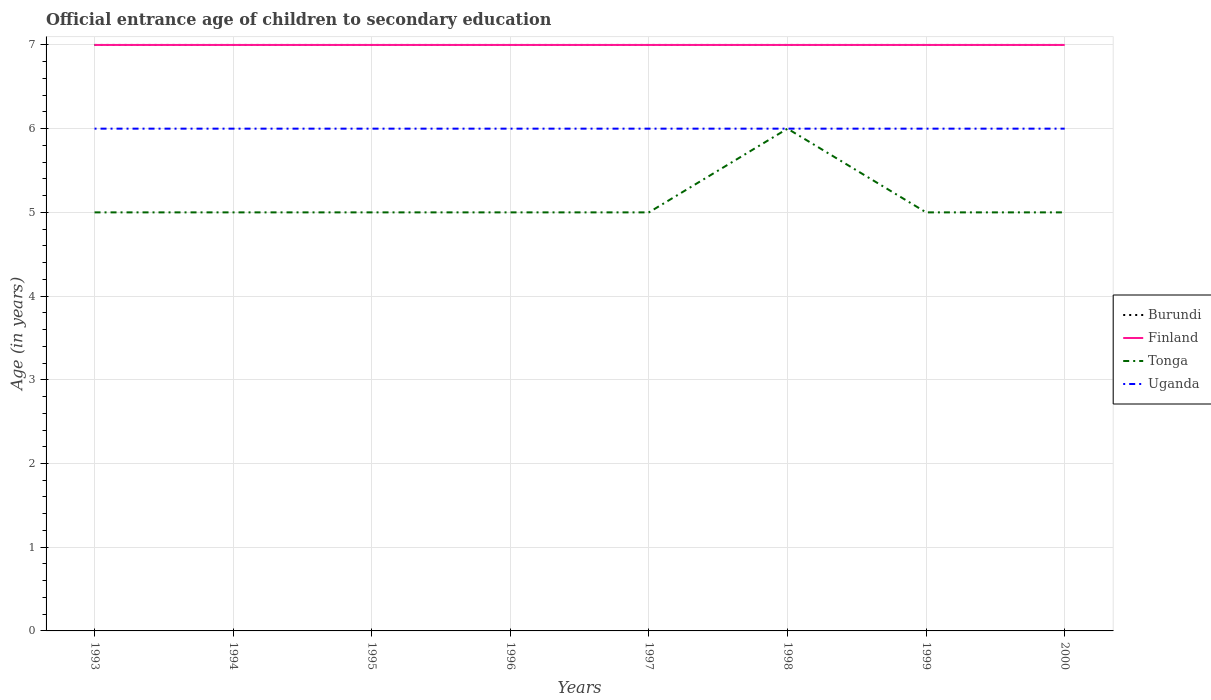How many different coloured lines are there?
Keep it short and to the point. 4. Across all years, what is the maximum secondary school starting age of children in Uganda?
Your response must be concise. 6. What is the difference between the highest and the second highest secondary school starting age of children in Tonga?
Your answer should be very brief. 1. Is the secondary school starting age of children in Tonga strictly greater than the secondary school starting age of children in Finland over the years?
Your answer should be very brief. Yes. Are the values on the major ticks of Y-axis written in scientific E-notation?
Give a very brief answer. No. Where does the legend appear in the graph?
Ensure brevity in your answer.  Center right. What is the title of the graph?
Your answer should be very brief. Official entrance age of children to secondary education. Does "Small states" appear as one of the legend labels in the graph?
Provide a short and direct response. No. What is the label or title of the Y-axis?
Offer a very short reply. Age (in years). What is the Age (in years) of Burundi in 1993?
Your response must be concise. 7. What is the Age (in years) of Tonga in 1993?
Keep it short and to the point. 5. What is the Age (in years) of Tonga in 1994?
Ensure brevity in your answer.  5. What is the Age (in years) of Uganda in 1994?
Ensure brevity in your answer.  6. What is the Age (in years) in Burundi in 1995?
Provide a short and direct response. 7. What is the Age (in years) of Finland in 1997?
Offer a terse response. 7. What is the Age (in years) of Tonga in 1997?
Make the answer very short. 5. What is the Age (in years) of Uganda in 1997?
Offer a very short reply. 6. What is the Age (in years) of Tonga in 1998?
Provide a succinct answer. 6. What is the Age (in years) in Burundi in 1999?
Give a very brief answer. 7. What is the Age (in years) in Finland in 1999?
Offer a terse response. 7. What is the Age (in years) of Burundi in 2000?
Offer a very short reply. 7. What is the Age (in years) in Tonga in 2000?
Your answer should be very brief. 5. Across all years, what is the maximum Age (in years) in Tonga?
Keep it short and to the point. 6. Across all years, what is the maximum Age (in years) of Uganda?
Your answer should be very brief. 6. Across all years, what is the minimum Age (in years) in Burundi?
Keep it short and to the point. 7. Across all years, what is the minimum Age (in years) in Finland?
Your response must be concise. 7. Across all years, what is the minimum Age (in years) in Tonga?
Provide a succinct answer. 5. Across all years, what is the minimum Age (in years) in Uganda?
Offer a very short reply. 6. What is the total Age (in years) of Tonga in the graph?
Your answer should be compact. 41. What is the difference between the Age (in years) of Burundi in 1993 and that in 1994?
Offer a terse response. 0. What is the difference between the Age (in years) in Tonga in 1993 and that in 1994?
Offer a very short reply. 0. What is the difference between the Age (in years) in Burundi in 1993 and that in 1995?
Provide a short and direct response. 0. What is the difference between the Age (in years) of Burundi in 1993 and that in 1996?
Your response must be concise. 0. What is the difference between the Age (in years) of Tonga in 1993 and that in 1996?
Ensure brevity in your answer.  0. What is the difference between the Age (in years) of Uganda in 1993 and that in 1996?
Provide a succinct answer. 0. What is the difference between the Age (in years) of Uganda in 1993 and that in 1997?
Provide a short and direct response. 0. What is the difference between the Age (in years) in Finland in 1993 and that in 1999?
Your answer should be compact. 0. What is the difference between the Age (in years) in Tonga in 1993 and that in 1999?
Offer a very short reply. 0. What is the difference between the Age (in years) of Uganda in 1993 and that in 1999?
Your response must be concise. 0. What is the difference between the Age (in years) of Finland in 1993 and that in 2000?
Offer a terse response. 0. What is the difference between the Age (in years) in Uganda in 1993 and that in 2000?
Your response must be concise. 0. What is the difference between the Age (in years) of Burundi in 1994 and that in 1995?
Your answer should be very brief. 0. What is the difference between the Age (in years) in Tonga in 1994 and that in 1995?
Offer a terse response. 0. What is the difference between the Age (in years) of Uganda in 1994 and that in 1995?
Your answer should be compact. 0. What is the difference between the Age (in years) of Finland in 1994 and that in 1996?
Offer a very short reply. 0. What is the difference between the Age (in years) in Uganda in 1994 and that in 1996?
Provide a succinct answer. 0. What is the difference between the Age (in years) of Finland in 1994 and that in 1997?
Your answer should be compact. 0. What is the difference between the Age (in years) in Tonga in 1994 and that in 1997?
Offer a terse response. 0. What is the difference between the Age (in years) in Burundi in 1994 and that in 1998?
Give a very brief answer. 0. What is the difference between the Age (in years) of Finland in 1994 and that in 1999?
Offer a terse response. 0. What is the difference between the Age (in years) in Tonga in 1994 and that in 1999?
Ensure brevity in your answer.  0. What is the difference between the Age (in years) in Uganda in 1994 and that in 1999?
Your answer should be compact. 0. What is the difference between the Age (in years) of Burundi in 1994 and that in 2000?
Give a very brief answer. 0. What is the difference between the Age (in years) in Uganda in 1994 and that in 2000?
Provide a short and direct response. 0. What is the difference between the Age (in years) of Burundi in 1995 and that in 1996?
Your answer should be very brief. 0. What is the difference between the Age (in years) in Tonga in 1995 and that in 1996?
Ensure brevity in your answer.  0. What is the difference between the Age (in years) of Burundi in 1995 and that in 1998?
Offer a very short reply. 0. What is the difference between the Age (in years) of Finland in 1995 and that in 1998?
Keep it short and to the point. 0. What is the difference between the Age (in years) in Tonga in 1995 and that in 1998?
Give a very brief answer. -1. What is the difference between the Age (in years) in Uganda in 1995 and that in 1998?
Your response must be concise. 0. What is the difference between the Age (in years) in Finland in 1995 and that in 1999?
Your answer should be very brief. 0. What is the difference between the Age (in years) of Burundi in 1995 and that in 2000?
Your response must be concise. 0. What is the difference between the Age (in years) in Uganda in 1995 and that in 2000?
Ensure brevity in your answer.  0. What is the difference between the Age (in years) in Uganda in 1996 and that in 1997?
Give a very brief answer. 0. What is the difference between the Age (in years) in Burundi in 1996 and that in 1998?
Your answer should be compact. 0. What is the difference between the Age (in years) in Finland in 1996 and that in 1998?
Provide a short and direct response. 0. What is the difference between the Age (in years) of Finland in 1996 and that in 1999?
Make the answer very short. 0. What is the difference between the Age (in years) in Burundi in 1996 and that in 2000?
Make the answer very short. 0. What is the difference between the Age (in years) in Finland in 1996 and that in 2000?
Your answer should be very brief. 0. What is the difference between the Age (in years) of Uganda in 1996 and that in 2000?
Offer a terse response. 0. What is the difference between the Age (in years) of Tonga in 1997 and that in 1998?
Your response must be concise. -1. What is the difference between the Age (in years) of Uganda in 1997 and that in 1998?
Provide a succinct answer. 0. What is the difference between the Age (in years) in Finland in 1997 and that in 1999?
Give a very brief answer. 0. What is the difference between the Age (in years) of Tonga in 1997 and that in 1999?
Make the answer very short. 0. What is the difference between the Age (in years) of Uganda in 1997 and that in 1999?
Make the answer very short. 0. What is the difference between the Age (in years) of Burundi in 1997 and that in 2000?
Keep it short and to the point. 0. What is the difference between the Age (in years) of Uganda in 1997 and that in 2000?
Give a very brief answer. 0. What is the difference between the Age (in years) of Burundi in 1998 and that in 1999?
Provide a succinct answer. 0. What is the difference between the Age (in years) of Tonga in 1998 and that in 1999?
Give a very brief answer. 1. What is the difference between the Age (in years) of Uganda in 1998 and that in 1999?
Offer a very short reply. 0. What is the difference between the Age (in years) of Finland in 1998 and that in 2000?
Your response must be concise. 0. What is the difference between the Age (in years) in Uganda in 1998 and that in 2000?
Your response must be concise. 0. What is the difference between the Age (in years) of Tonga in 1999 and that in 2000?
Offer a terse response. 0. What is the difference between the Age (in years) of Burundi in 1993 and the Age (in years) of Tonga in 1994?
Provide a succinct answer. 2. What is the difference between the Age (in years) of Tonga in 1993 and the Age (in years) of Uganda in 1994?
Your answer should be compact. -1. What is the difference between the Age (in years) of Burundi in 1993 and the Age (in years) of Finland in 1995?
Offer a very short reply. 0. What is the difference between the Age (in years) in Burundi in 1993 and the Age (in years) in Uganda in 1995?
Provide a succinct answer. 1. What is the difference between the Age (in years) of Finland in 1993 and the Age (in years) of Tonga in 1995?
Your response must be concise. 2. What is the difference between the Age (in years) of Burundi in 1993 and the Age (in years) of Finland in 1996?
Your response must be concise. 0. What is the difference between the Age (in years) of Burundi in 1993 and the Age (in years) of Finland in 1997?
Your answer should be very brief. 0. What is the difference between the Age (in years) in Burundi in 1993 and the Age (in years) in Finland in 1998?
Your answer should be very brief. 0. What is the difference between the Age (in years) of Burundi in 1993 and the Age (in years) of Uganda in 1998?
Offer a very short reply. 1. What is the difference between the Age (in years) of Finland in 1993 and the Age (in years) of Tonga in 1998?
Offer a very short reply. 1. What is the difference between the Age (in years) in Tonga in 1993 and the Age (in years) in Uganda in 1998?
Provide a succinct answer. -1. What is the difference between the Age (in years) in Finland in 1993 and the Age (in years) in Tonga in 1999?
Make the answer very short. 2. What is the difference between the Age (in years) in Tonga in 1993 and the Age (in years) in Uganda in 1999?
Keep it short and to the point. -1. What is the difference between the Age (in years) of Burundi in 1993 and the Age (in years) of Tonga in 2000?
Your response must be concise. 2. What is the difference between the Age (in years) of Finland in 1993 and the Age (in years) of Tonga in 2000?
Ensure brevity in your answer.  2. What is the difference between the Age (in years) of Finland in 1993 and the Age (in years) of Uganda in 2000?
Provide a short and direct response. 1. What is the difference between the Age (in years) of Burundi in 1994 and the Age (in years) of Uganda in 1995?
Your answer should be compact. 1. What is the difference between the Age (in years) in Finland in 1994 and the Age (in years) in Uganda in 1995?
Provide a succinct answer. 1. What is the difference between the Age (in years) of Tonga in 1994 and the Age (in years) of Uganda in 1995?
Offer a very short reply. -1. What is the difference between the Age (in years) of Burundi in 1994 and the Age (in years) of Tonga in 1996?
Your response must be concise. 2. What is the difference between the Age (in years) in Finland in 1994 and the Age (in years) in Tonga in 1996?
Provide a short and direct response. 2. What is the difference between the Age (in years) in Burundi in 1994 and the Age (in years) in Finland in 1997?
Your answer should be compact. 0. What is the difference between the Age (in years) in Burundi in 1994 and the Age (in years) in Tonga in 1997?
Ensure brevity in your answer.  2. What is the difference between the Age (in years) in Finland in 1994 and the Age (in years) in Tonga in 1997?
Provide a succinct answer. 2. What is the difference between the Age (in years) in Burundi in 1994 and the Age (in years) in Finland in 1998?
Make the answer very short. 0. What is the difference between the Age (in years) in Burundi in 1994 and the Age (in years) in Uganda in 1998?
Offer a very short reply. 1. What is the difference between the Age (in years) of Burundi in 1994 and the Age (in years) of Finland in 1999?
Provide a short and direct response. 0. What is the difference between the Age (in years) in Burundi in 1994 and the Age (in years) in Tonga in 1999?
Your response must be concise. 2. What is the difference between the Age (in years) of Burundi in 1994 and the Age (in years) of Uganda in 1999?
Offer a very short reply. 1. What is the difference between the Age (in years) of Finland in 1994 and the Age (in years) of Tonga in 1999?
Provide a short and direct response. 2. What is the difference between the Age (in years) of Tonga in 1994 and the Age (in years) of Uganda in 1999?
Make the answer very short. -1. What is the difference between the Age (in years) in Burundi in 1994 and the Age (in years) in Finland in 2000?
Give a very brief answer. 0. What is the difference between the Age (in years) of Tonga in 1994 and the Age (in years) of Uganda in 2000?
Offer a terse response. -1. What is the difference between the Age (in years) of Burundi in 1995 and the Age (in years) of Tonga in 1996?
Make the answer very short. 2. What is the difference between the Age (in years) in Finland in 1995 and the Age (in years) in Tonga in 1996?
Your answer should be very brief. 2. What is the difference between the Age (in years) of Finland in 1995 and the Age (in years) of Uganda in 1996?
Make the answer very short. 1. What is the difference between the Age (in years) in Tonga in 1995 and the Age (in years) in Uganda in 1996?
Ensure brevity in your answer.  -1. What is the difference between the Age (in years) of Burundi in 1995 and the Age (in years) of Tonga in 1997?
Provide a succinct answer. 2. What is the difference between the Age (in years) of Finland in 1995 and the Age (in years) of Uganda in 1997?
Provide a short and direct response. 1. What is the difference between the Age (in years) of Tonga in 1995 and the Age (in years) of Uganda in 1997?
Offer a very short reply. -1. What is the difference between the Age (in years) of Burundi in 1995 and the Age (in years) of Uganda in 1998?
Keep it short and to the point. 1. What is the difference between the Age (in years) in Finland in 1995 and the Age (in years) in Uganda in 1998?
Offer a very short reply. 1. What is the difference between the Age (in years) in Burundi in 1995 and the Age (in years) in Tonga in 1999?
Give a very brief answer. 2. What is the difference between the Age (in years) in Burundi in 1995 and the Age (in years) in Finland in 2000?
Provide a short and direct response. 0. What is the difference between the Age (in years) in Burundi in 1995 and the Age (in years) in Tonga in 2000?
Offer a terse response. 2. What is the difference between the Age (in years) in Burundi in 1995 and the Age (in years) in Uganda in 2000?
Your response must be concise. 1. What is the difference between the Age (in years) in Finland in 1995 and the Age (in years) in Tonga in 2000?
Give a very brief answer. 2. What is the difference between the Age (in years) of Finland in 1995 and the Age (in years) of Uganda in 2000?
Your response must be concise. 1. What is the difference between the Age (in years) of Tonga in 1995 and the Age (in years) of Uganda in 2000?
Give a very brief answer. -1. What is the difference between the Age (in years) of Burundi in 1996 and the Age (in years) of Tonga in 1997?
Your response must be concise. 2. What is the difference between the Age (in years) of Burundi in 1996 and the Age (in years) of Uganda in 1997?
Offer a terse response. 1. What is the difference between the Age (in years) of Finland in 1996 and the Age (in years) of Uganda in 1997?
Provide a short and direct response. 1. What is the difference between the Age (in years) of Burundi in 1996 and the Age (in years) of Finland in 1998?
Ensure brevity in your answer.  0. What is the difference between the Age (in years) of Burundi in 1996 and the Age (in years) of Tonga in 1998?
Offer a very short reply. 1. What is the difference between the Age (in years) of Burundi in 1996 and the Age (in years) of Uganda in 1998?
Your response must be concise. 1. What is the difference between the Age (in years) of Burundi in 1996 and the Age (in years) of Tonga in 1999?
Your response must be concise. 2. What is the difference between the Age (in years) of Burundi in 1996 and the Age (in years) of Finland in 2000?
Your response must be concise. 0. What is the difference between the Age (in years) of Burundi in 1996 and the Age (in years) of Tonga in 2000?
Provide a short and direct response. 2. What is the difference between the Age (in years) of Finland in 1996 and the Age (in years) of Tonga in 2000?
Provide a short and direct response. 2. What is the difference between the Age (in years) in Burundi in 1997 and the Age (in years) in Tonga in 1998?
Your answer should be compact. 1. What is the difference between the Age (in years) of Finland in 1997 and the Age (in years) of Uganda in 1998?
Make the answer very short. 1. What is the difference between the Age (in years) in Burundi in 1997 and the Age (in years) in Finland in 1999?
Offer a terse response. 0. What is the difference between the Age (in years) of Burundi in 1997 and the Age (in years) of Uganda in 1999?
Offer a terse response. 1. What is the difference between the Age (in years) of Finland in 1997 and the Age (in years) of Tonga in 1999?
Ensure brevity in your answer.  2. What is the difference between the Age (in years) of Tonga in 1997 and the Age (in years) of Uganda in 1999?
Provide a short and direct response. -1. What is the difference between the Age (in years) in Burundi in 1997 and the Age (in years) in Uganda in 2000?
Your answer should be compact. 1. What is the difference between the Age (in years) of Finland in 1997 and the Age (in years) of Uganda in 2000?
Provide a succinct answer. 1. What is the difference between the Age (in years) in Tonga in 1997 and the Age (in years) in Uganda in 2000?
Provide a short and direct response. -1. What is the difference between the Age (in years) of Burundi in 1998 and the Age (in years) of Finland in 1999?
Offer a very short reply. 0. What is the difference between the Age (in years) of Burundi in 1998 and the Age (in years) of Tonga in 1999?
Give a very brief answer. 2. What is the difference between the Age (in years) of Burundi in 1998 and the Age (in years) of Uganda in 1999?
Give a very brief answer. 1. What is the difference between the Age (in years) of Finland in 1998 and the Age (in years) of Uganda in 1999?
Give a very brief answer. 1. What is the difference between the Age (in years) of Burundi in 1998 and the Age (in years) of Finland in 2000?
Your answer should be very brief. 0. What is the difference between the Age (in years) of Tonga in 1998 and the Age (in years) of Uganda in 2000?
Make the answer very short. 0. What is the difference between the Age (in years) of Burundi in 1999 and the Age (in years) of Finland in 2000?
Provide a succinct answer. 0. What is the difference between the Age (in years) of Finland in 1999 and the Age (in years) of Tonga in 2000?
Your answer should be compact. 2. What is the difference between the Age (in years) of Finland in 1999 and the Age (in years) of Uganda in 2000?
Your answer should be very brief. 1. What is the difference between the Age (in years) in Tonga in 1999 and the Age (in years) in Uganda in 2000?
Your response must be concise. -1. What is the average Age (in years) in Burundi per year?
Your response must be concise. 7. What is the average Age (in years) in Finland per year?
Offer a very short reply. 7. What is the average Age (in years) of Tonga per year?
Offer a very short reply. 5.12. What is the average Age (in years) in Uganda per year?
Provide a succinct answer. 6. In the year 1993, what is the difference between the Age (in years) of Burundi and Age (in years) of Tonga?
Provide a succinct answer. 2. In the year 1993, what is the difference between the Age (in years) of Finland and Age (in years) of Tonga?
Offer a very short reply. 2. In the year 1993, what is the difference between the Age (in years) in Finland and Age (in years) in Uganda?
Offer a terse response. 1. In the year 1994, what is the difference between the Age (in years) in Burundi and Age (in years) in Tonga?
Your answer should be very brief. 2. In the year 1994, what is the difference between the Age (in years) of Burundi and Age (in years) of Uganda?
Give a very brief answer. 1. In the year 1994, what is the difference between the Age (in years) of Finland and Age (in years) of Tonga?
Provide a succinct answer. 2. In the year 1994, what is the difference between the Age (in years) in Finland and Age (in years) in Uganda?
Your response must be concise. 1. In the year 1995, what is the difference between the Age (in years) in Burundi and Age (in years) in Finland?
Keep it short and to the point. 0. In the year 1995, what is the difference between the Age (in years) of Burundi and Age (in years) of Tonga?
Your answer should be compact. 2. In the year 1996, what is the difference between the Age (in years) in Burundi and Age (in years) in Uganda?
Make the answer very short. 1. In the year 1997, what is the difference between the Age (in years) of Burundi and Age (in years) of Tonga?
Offer a terse response. 2. In the year 1997, what is the difference between the Age (in years) in Tonga and Age (in years) in Uganda?
Ensure brevity in your answer.  -1. In the year 1998, what is the difference between the Age (in years) in Burundi and Age (in years) in Finland?
Ensure brevity in your answer.  0. In the year 1998, what is the difference between the Age (in years) in Burundi and Age (in years) in Uganda?
Give a very brief answer. 1. In the year 1998, what is the difference between the Age (in years) in Finland and Age (in years) in Uganda?
Offer a terse response. 1. In the year 1999, what is the difference between the Age (in years) in Burundi and Age (in years) in Finland?
Give a very brief answer. 0. In the year 1999, what is the difference between the Age (in years) of Burundi and Age (in years) of Tonga?
Keep it short and to the point. 2. In the year 1999, what is the difference between the Age (in years) of Burundi and Age (in years) of Uganda?
Offer a very short reply. 1. In the year 1999, what is the difference between the Age (in years) in Finland and Age (in years) in Tonga?
Your answer should be very brief. 2. In the year 2000, what is the difference between the Age (in years) in Burundi and Age (in years) in Finland?
Offer a terse response. 0. In the year 2000, what is the difference between the Age (in years) in Burundi and Age (in years) in Uganda?
Your response must be concise. 1. In the year 2000, what is the difference between the Age (in years) in Finland and Age (in years) in Tonga?
Your answer should be very brief. 2. What is the ratio of the Age (in years) of Burundi in 1993 to that in 1994?
Your response must be concise. 1. What is the ratio of the Age (in years) in Finland in 1993 to that in 1994?
Your response must be concise. 1. What is the ratio of the Age (in years) of Uganda in 1993 to that in 1994?
Ensure brevity in your answer.  1. What is the ratio of the Age (in years) of Burundi in 1993 to that in 1995?
Make the answer very short. 1. What is the ratio of the Age (in years) of Finland in 1993 to that in 1995?
Provide a succinct answer. 1. What is the ratio of the Age (in years) of Uganda in 1993 to that in 1995?
Offer a very short reply. 1. What is the ratio of the Age (in years) of Finland in 1993 to that in 1996?
Give a very brief answer. 1. What is the ratio of the Age (in years) in Uganda in 1993 to that in 1996?
Your response must be concise. 1. What is the ratio of the Age (in years) of Tonga in 1993 to that in 1997?
Give a very brief answer. 1. What is the ratio of the Age (in years) of Uganda in 1993 to that in 1997?
Offer a very short reply. 1. What is the ratio of the Age (in years) in Burundi in 1993 to that in 1998?
Make the answer very short. 1. What is the ratio of the Age (in years) of Tonga in 1993 to that in 1999?
Your response must be concise. 1. What is the ratio of the Age (in years) in Uganda in 1993 to that in 1999?
Your answer should be very brief. 1. What is the ratio of the Age (in years) of Uganda in 1993 to that in 2000?
Your answer should be very brief. 1. What is the ratio of the Age (in years) in Burundi in 1994 to that in 1995?
Offer a terse response. 1. What is the ratio of the Age (in years) of Uganda in 1994 to that in 1996?
Your answer should be compact. 1. What is the ratio of the Age (in years) of Burundi in 1994 to that in 1998?
Your response must be concise. 1. What is the ratio of the Age (in years) in Finland in 1994 to that in 1998?
Your response must be concise. 1. What is the ratio of the Age (in years) of Burundi in 1994 to that in 1999?
Give a very brief answer. 1. What is the ratio of the Age (in years) of Finland in 1994 to that in 1999?
Give a very brief answer. 1. What is the ratio of the Age (in years) in Uganda in 1994 to that in 1999?
Provide a succinct answer. 1. What is the ratio of the Age (in years) of Finland in 1994 to that in 2000?
Make the answer very short. 1. What is the ratio of the Age (in years) in Uganda in 1994 to that in 2000?
Offer a terse response. 1. What is the ratio of the Age (in years) of Finland in 1995 to that in 1996?
Make the answer very short. 1. What is the ratio of the Age (in years) in Burundi in 1995 to that in 1997?
Offer a terse response. 1. What is the ratio of the Age (in years) in Tonga in 1995 to that in 1997?
Your answer should be compact. 1. What is the ratio of the Age (in years) of Uganda in 1995 to that in 1997?
Offer a terse response. 1. What is the ratio of the Age (in years) in Burundi in 1995 to that in 1998?
Give a very brief answer. 1. What is the ratio of the Age (in years) of Finland in 1995 to that in 1998?
Your answer should be very brief. 1. What is the ratio of the Age (in years) in Uganda in 1995 to that in 1998?
Your response must be concise. 1. What is the ratio of the Age (in years) in Burundi in 1995 to that in 1999?
Your answer should be very brief. 1. What is the ratio of the Age (in years) of Burundi in 1995 to that in 2000?
Offer a terse response. 1. What is the ratio of the Age (in years) of Finland in 1995 to that in 2000?
Provide a succinct answer. 1. What is the ratio of the Age (in years) of Finland in 1996 to that in 1997?
Make the answer very short. 1. What is the ratio of the Age (in years) in Uganda in 1996 to that in 1997?
Offer a terse response. 1. What is the ratio of the Age (in years) in Tonga in 1996 to that in 1999?
Ensure brevity in your answer.  1. What is the ratio of the Age (in years) of Uganda in 1996 to that in 1999?
Ensure brevity in your answer.  1. What is the ratio of the Age (in years) of Tonga in 1996 to that in 2000?
Provide a short and direct response. 1. What is the ratio of the Age (in years) in Uganda in 1996 to that in 2000?
Your response must be concise. 1. What is the ratio of the Age (in years) in Burundi in 1997 to that in 1999?
Your answer should be compact. 1. What is the ratio of the Age (in years) of Tonga in 1997 to that in 1999?
Provide a succinct answer. 1. What is the ratio of the Age (in years) in Burundi in 1997 to that in 2000?
Make the answer very short. 1. What is the ratio of the Age (in years) of Tonga in 1997 to that in 2000?
Make the answer very short. 1. What is the ratio of the Age (in years) in Burundi in 1998 to that in 1999?
Offer a very short reply. 1. What is the ratio of the Age (in years) of Tonga in 1998 to that in 1999?
Offer a terse response. 1.2. What is the ratio of the Age (in years) of Uganda in 1999 to that in 2000?
Offer a terse response. 1. What is the difference between the highest and the second highest Age (in years) in Burundi?
Offer a very short reply. 0. What is the difference between the highest and the second highest Age (in years) in Uganda?
Your response must be concise. 0. What is the difference between the highest and the lowest Age (in years) of Burundi?
Offer a very short reply. 0. What is the difference between the highest and the lowest Age (in years) of Finland?
Ensure brevity in your answer.  0. What is the difference between the highest and the lowest Age (in years) of Uganda?
Your response must be concise. 0. 